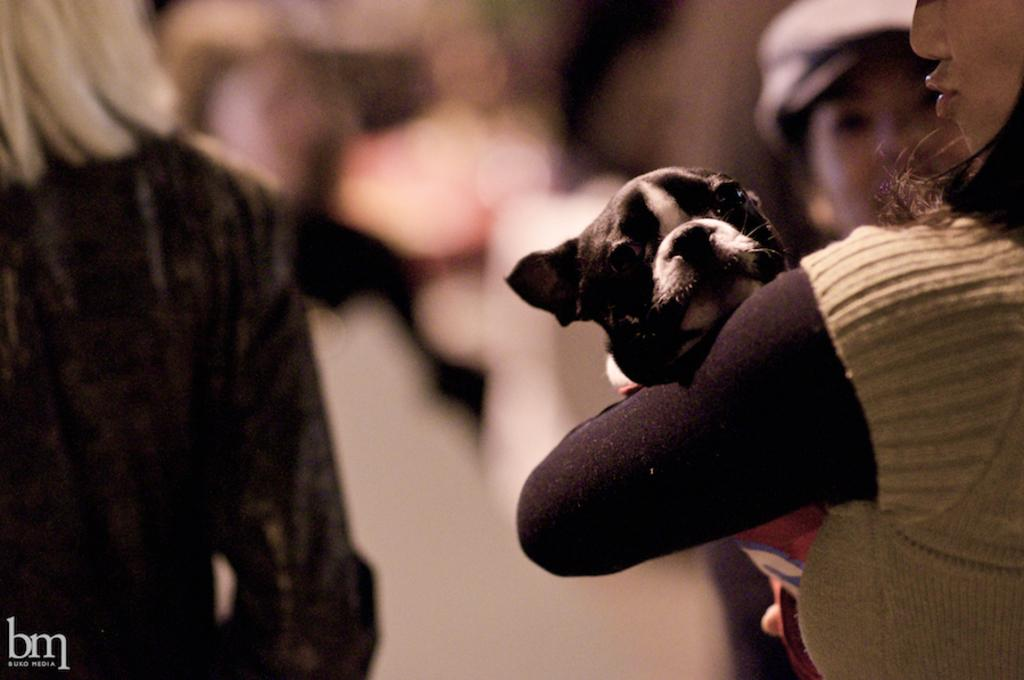Who is present in the picture? There are women in the picture. What is one of the women doing in the picture? A woman is holding a dog. What can be found at the bottom left corner of the picture? There is text at the bottom left corner of the picture. How would you describe the background of the picture? The background of the picture is blurry. How many ladybugs can be seen on the dog in the picture? There are no ladybugs present in the image, so it is not possible to determine how many might be on the dog. 